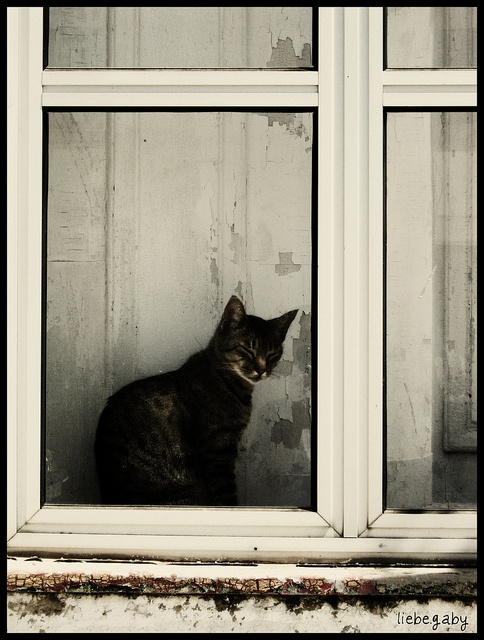Describe the objects in this image and their specific colors. I can see a cat in black, gray, and darkgray tones in this image. 